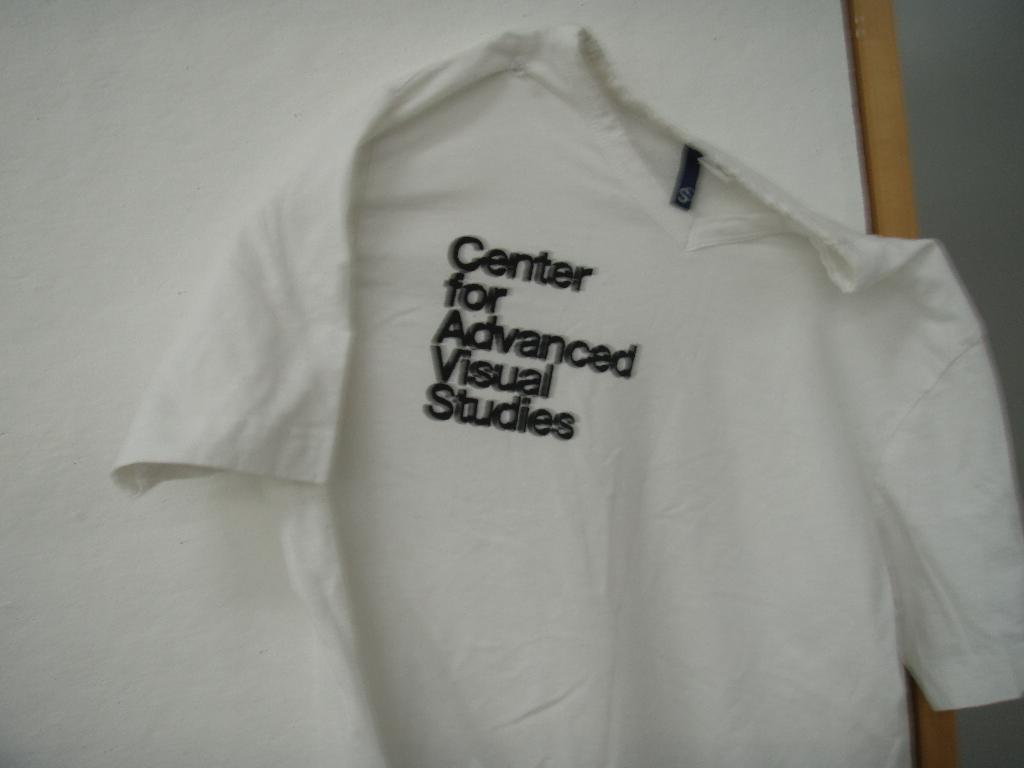<image>
Render a clear and concise summary of the photo. The shirt from the Center for advanced visual sudies 